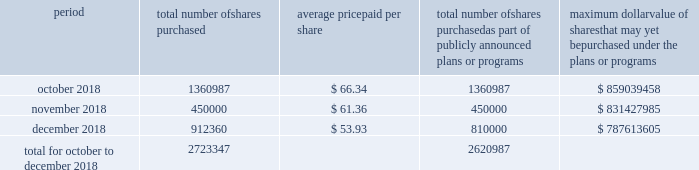Table of content part ii item 5 .
Market for the registrant's common equity , related stockholder matters and issuer purchases of equity securities our common stock is traded on the new york stock exchange under the trading symbol 201chfc . 201d in september 2018 , our board of directors approved a $ 1 billion share repurchase program , which replaced all existing share repurchase programs , authorizing us to repurchase common stock in the open market or through privately negotiated transactions .
The timing and amount of stock repurchases will depend on market conditions and corporate , regulatory and other relevant considerations .
This program may be discontinued at any time by the board of directors .
The table includes repurchases made under this program during the fourth quarter of 2018 .
Period total number of shares purchased average price paid per share total number of shares purchased as part of publicly announced plans or programs maximum dollar value of shares that may yet be purchased under the plans or programs .
During the quarter ended december 31 , 2018 , 102360 shares were withheld from certain executives and employees under the terms of our share-based compensation agreements to provide funds for the payment of payroll and income taxes due at vesting of restricted stock awards .
As of february 13 , 2019 , we had approximately 97419 stockholders , including beneficial owners holding shares in street name .
We intend to consider the declaration of a dividend on a quarterly basis , although there is no assurance as to future dividends since they are dependent upon future earnings , capital requirements , our financial condition and other factors. .
In october 2018 , what was the total cost for repurchasing the 1360987 shares? 
Computations: (66.34 * 1360987)
Answer: 90287877.58. 